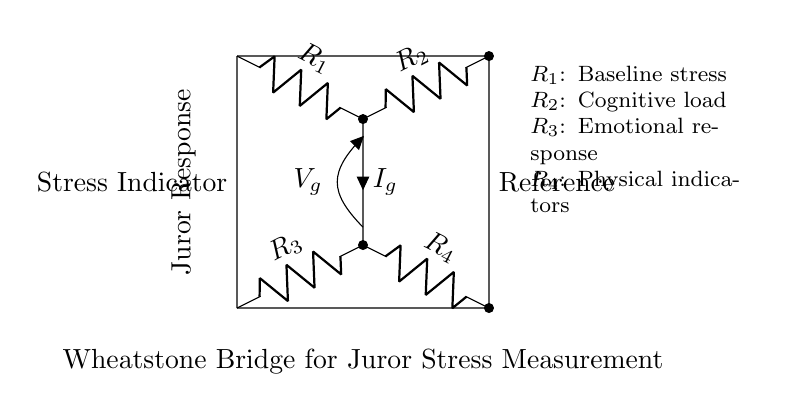What is the type of circuit shown? This is a Wheatstone Bridge circuit, which is used to measure unknown resistances by balancing two legs of a bridge circuit.
Answer: Wheatstone Bridge What do the resistors represent? The resistors represent different types of stress responses: R1 is baseline stress, R2 is cognitive load, R3 is emotional response, and R4 is physical indicators.
Answer: Different stress responses What is the connection between R1 and R2? R1 and R2 are connected in series, forming one leg of the Wheatstone Bridge. This connection allows for the comparison of the voltages across each leg of the bridge.
Answer: Series connection What is the significance of the voltage Vg? Vg represents the voltage difference between the two nodes of the bridge created by the stress responses which indicates the level of stress experienced by the juror.
Answer: Juror stress level What is the role of the stress indicator in this circuit? The stress indicator measures the voltage difference caused by the imbalance in resistances in the Wheatstone Bridge, which translates to the juror's stress level.
Answer: Measure stress levels How many resistor components are in the circuit? There are four resistors in the Wheatstone Bridge: R1, R2, R3, and R4.
Answer: Four resistors What parameters could be adjusted to influence the measurement? The values of R1, R2, R3, and R4 can be adjusted to influence the balance of the circuit and thereby affect the voltage Vg indicating stress levels.
Answer: Resistor values 